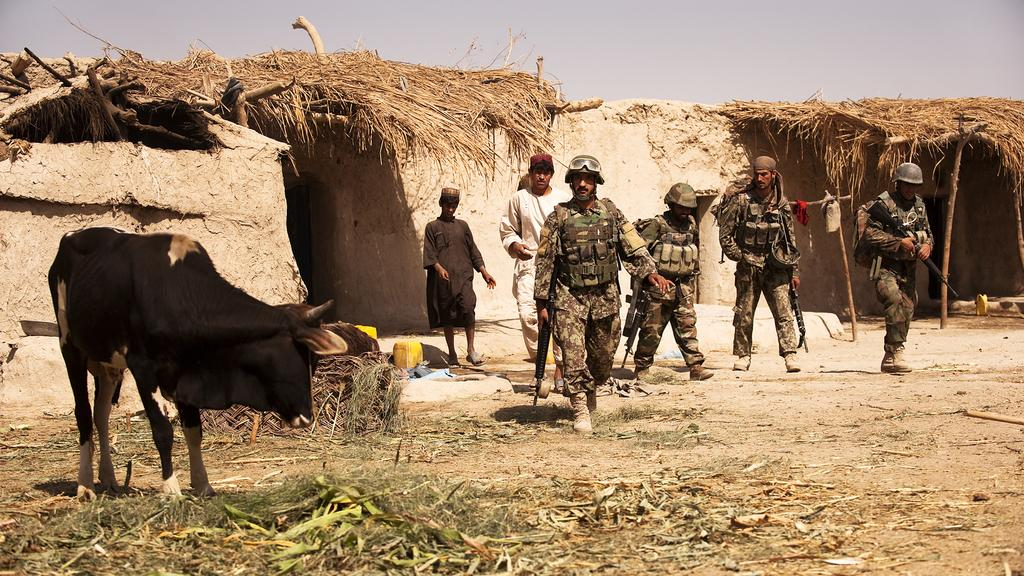How many people are in the image? There are four people in the image. What are the people wearing? The people are wearing military dress. What are the people holding in the image? The people are holding guns. Can you describe the animal visible in the image? There is an animal visible in the image, but the specific type of animal is not mentioned in the facts. What type of structures can be seen in the image? There are houses in the image. What type of school can be seen in the image? There is no school present in the image. How does the animal feel about being in the image? The facts provided do not give any information about the animal's feelings or emotions. 